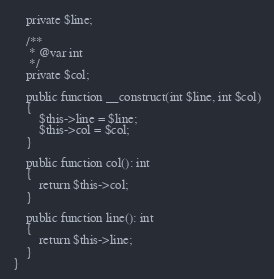<code> <loc_0><loc_0><loc_500><loc_500><_PHP_>    private $line;

    /**
     * @var int
     */
    private $col;

    public function __construct(int $line, int $col)
    {
        $this->line = $line;
        $this->col = $col;
    }

    public function col(): int
    {
        return $this->col;
    }

    public function line(): int
    {
        return $this->line;
    }
}
</code> 